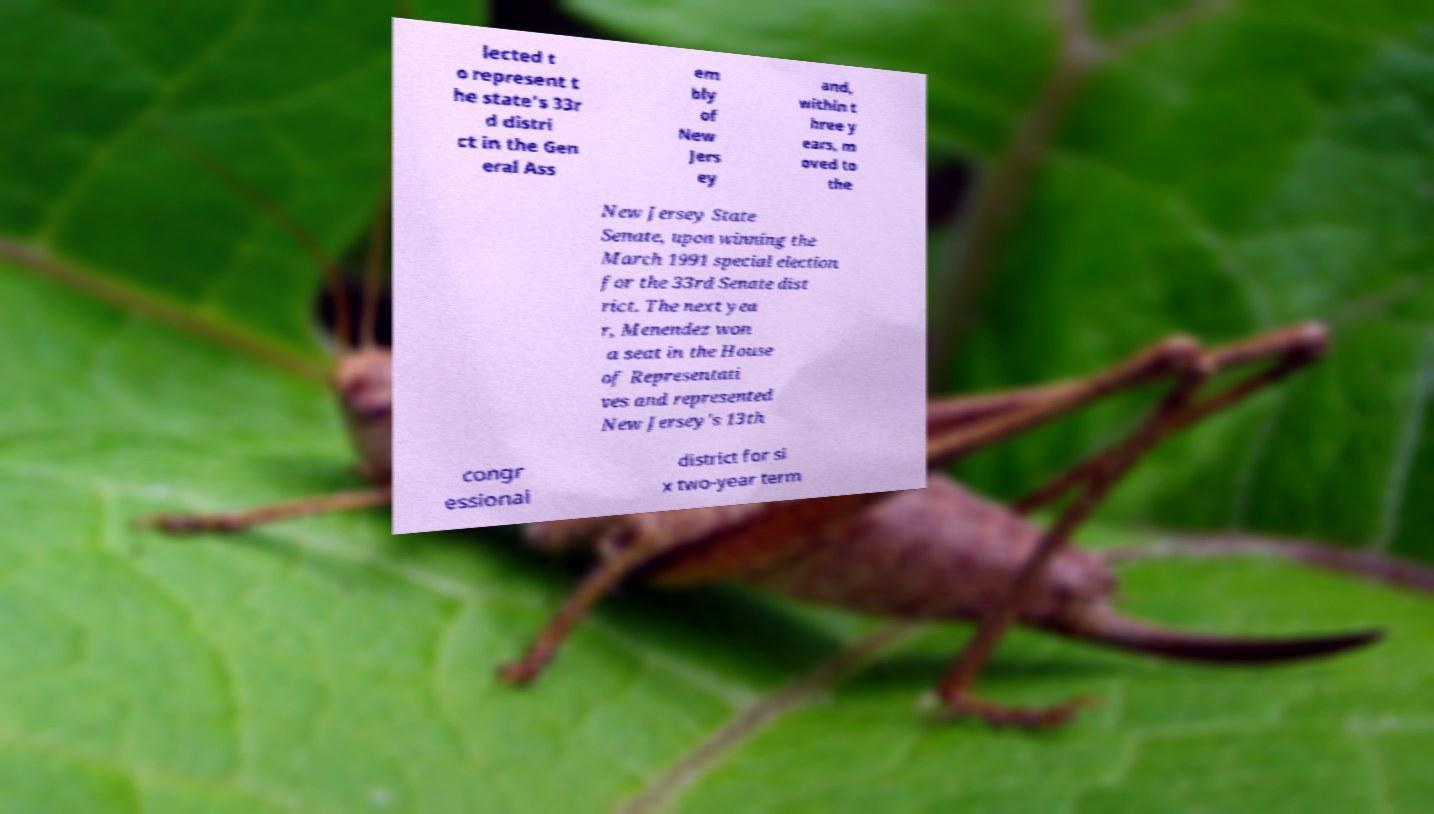What messages or text are displayed in this image? I need them in a readable, typed format. lected t o represent t he state's 33r d distri ct in the Gen eral Ass em bly of New Jers ey and, within t hree y ears, m oved to the New Jersey State Senate, upon winning the March 1991 special election for the 33rd Senate dist rict. The next yea r, Menendez won a seat in the House of Representati ves and represented New Jersey's 13th congr essional district for si x two-year term 